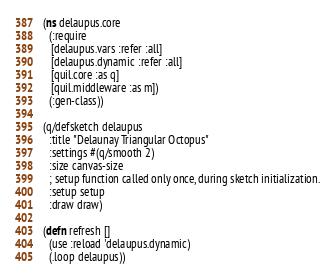Convert code to text. <code><loc_0><loc_0><loc_500><loc_500><_Clojure_>(ns delaupus.core
  (:require 
   [delaupus.vars :refer :all]
   [delaupus.dynamic :refer :all]
   [quil.core :as q]
   [quil.middleware :as m])
  (:gen-class))

(q/defsketch delaupus
  :title "Delaunay Triangular Octopus"
  :settings #(q/smooth 2)
  :size canvas-size
  ; setup function called only once, during sketch initialization.
  :setup setup
  :draw draw)

(defn refresh []
  (use :reload 'delaupus.dynamic)
  (.loop delaupus))
</code> 